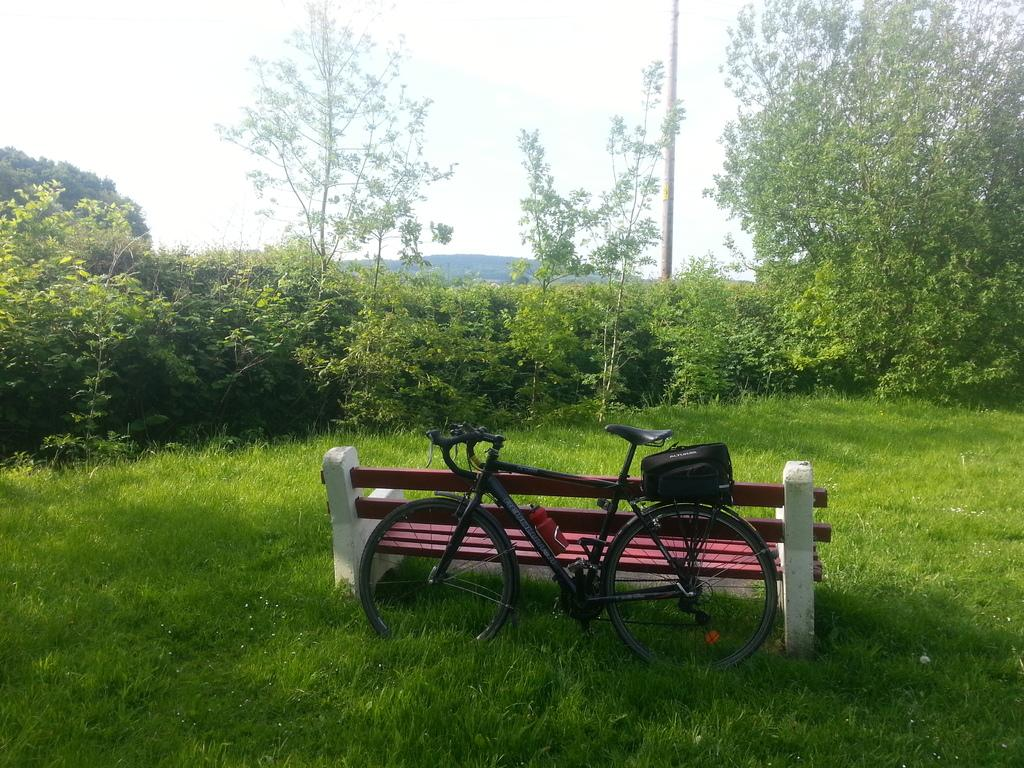What type of seating is present in the image? There is a bench in the image. What mode of transportation can be seen in the image? There is a bicycle in the image. What type of natural environment is visible in the image? There is grass, plants, and trees visible in the image. What structure is present in the image? There is a pole in the image. What is visible in the sky in the image? The sky is visible in the image. Where is the cub playing with the apple in the image? There is no cub or apple present in the image. What type of animal is grazing on the grass in the image? There is no animal visible in the image; only a bench, bicycle, pole, and plants are present. 